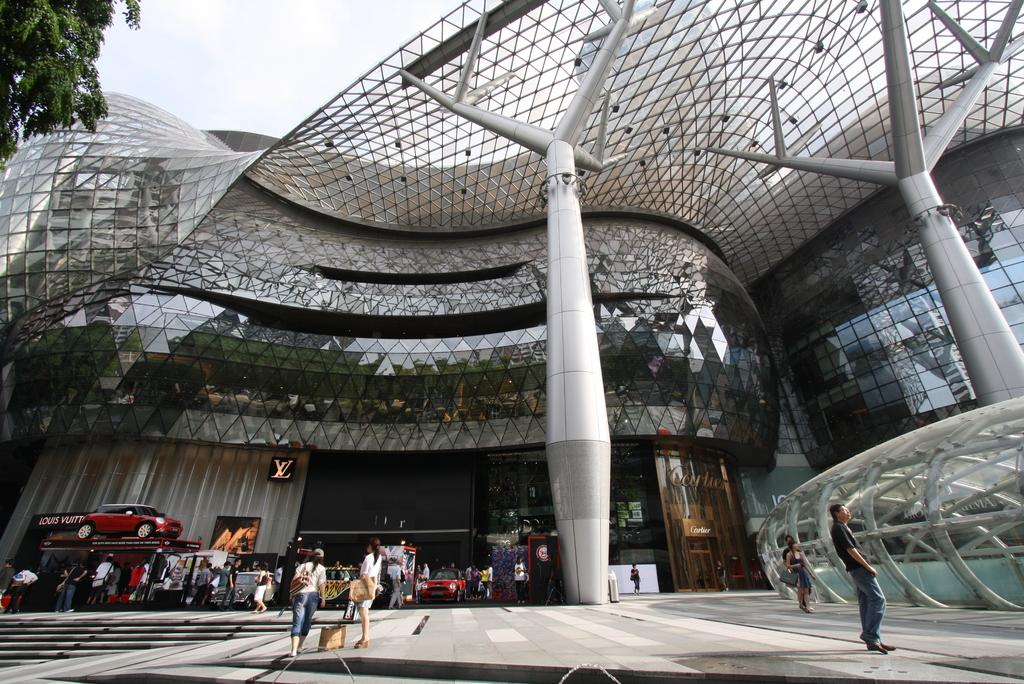What is the main event or activity taking place in the image? There is a car expo in the image. Are there any other businesses or establishments visible in the image? Yes, there are other stores in the image. What can be seen outside the mall or building in the image? There is a tree visible outside the mall. What type of office can be seen in the image? There is no office present in the image; it features a car expo and other stores. What class is being taught in the image? There is no class taking place in the image; it focuses on the car expo and other stores. 